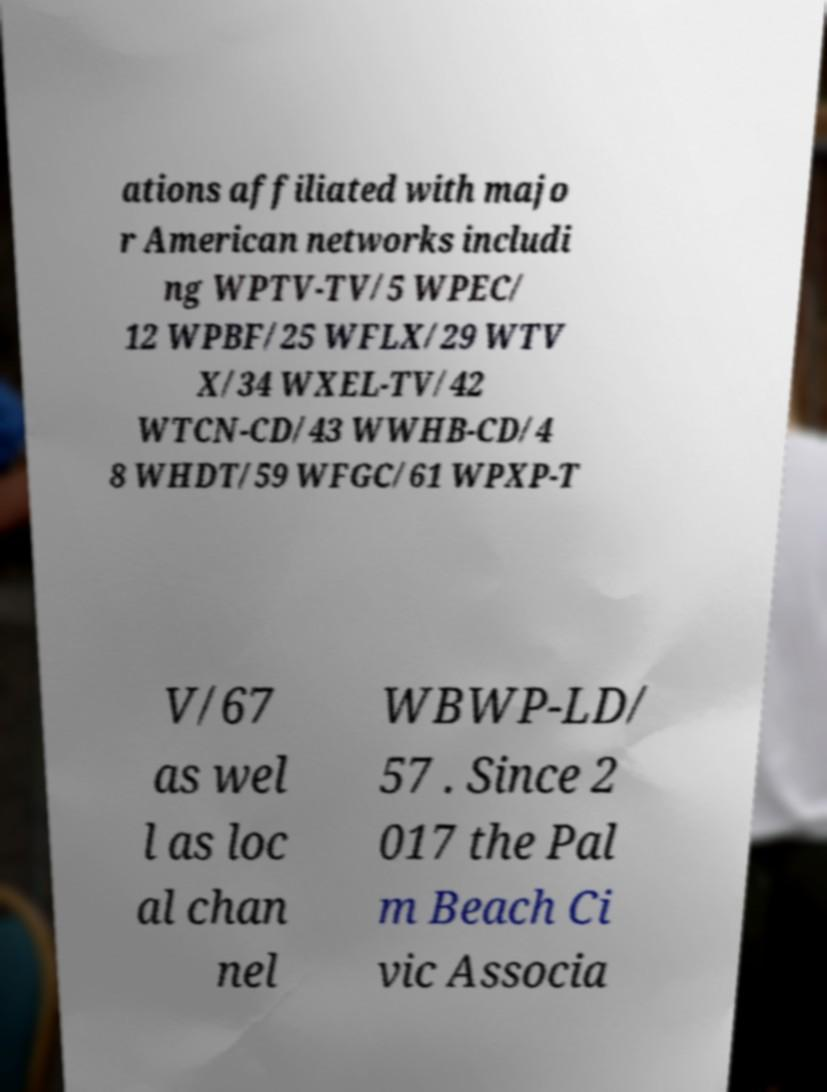Can you read and provide the text displayed in the image?This photo seems to have some interesting text. Can you extract and type it out for me? ations affiliated with majo r American networks includi ng WPTV-TV/5 WPEC/ 12 WPBF/25 WFLX/29 WTV X/34 WXEL-TV/42 WTCN-CD/43 WWHB-CD/4 8 WHDT/59 WFGC/61 WPXP-T V/67 as wel l as loc al chan nel WBWP-LD/ 57 . Since 2 017 the Pal m Beach Ci vic Associa 